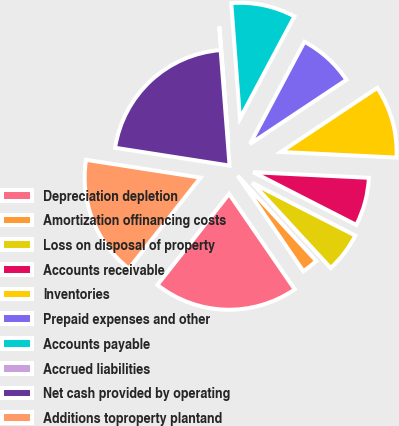Convert chart to OTSL. <chart><loc_0><loc_0><loc_500><loc_500><pie_chart><fcel>Depreciation depletion<fcel>Amortization offinancing costs<fcel>Loss on disposal of property<fcel>Accounts receivable<fcel>Inventories<fcel>Prepaid expenses and other<fcel>Accounts payable<fcel>Accrued liabilities<fcel>Net cash provided by operating<fcel>Additions toproperty plantand<nl><fcel>20.2%<fcel>2.27%<fcel>5.63%<fcel>6.75%<fcel>10.11%<fcel>7.87%<fcel>8.99%<fcel>0.03%<fcel>21.32%<fcel>16.84%<nl></chart> 